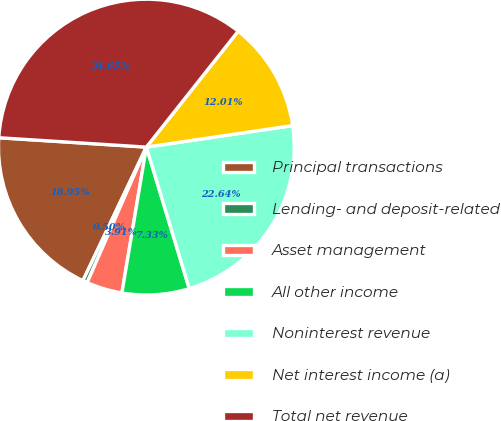Convert chart to OTSL. <chart><loc_0><loc_0><loc_500><loc_500><pie_chart><fcel>Principal transactions<fcel>Lending- and deposit-related<fcel>Asset management<fcel>All other income<fcel>Noninterest revenue<fcel>Net interest income (a)<fcel>Total net revenue<nl><fcel>18.95%<fcel>0.5%<fcel>3.91%<fcel>7.33%<fcel>22.64%<fcel>12.01%<fcel>34.65%<nl></chart> 